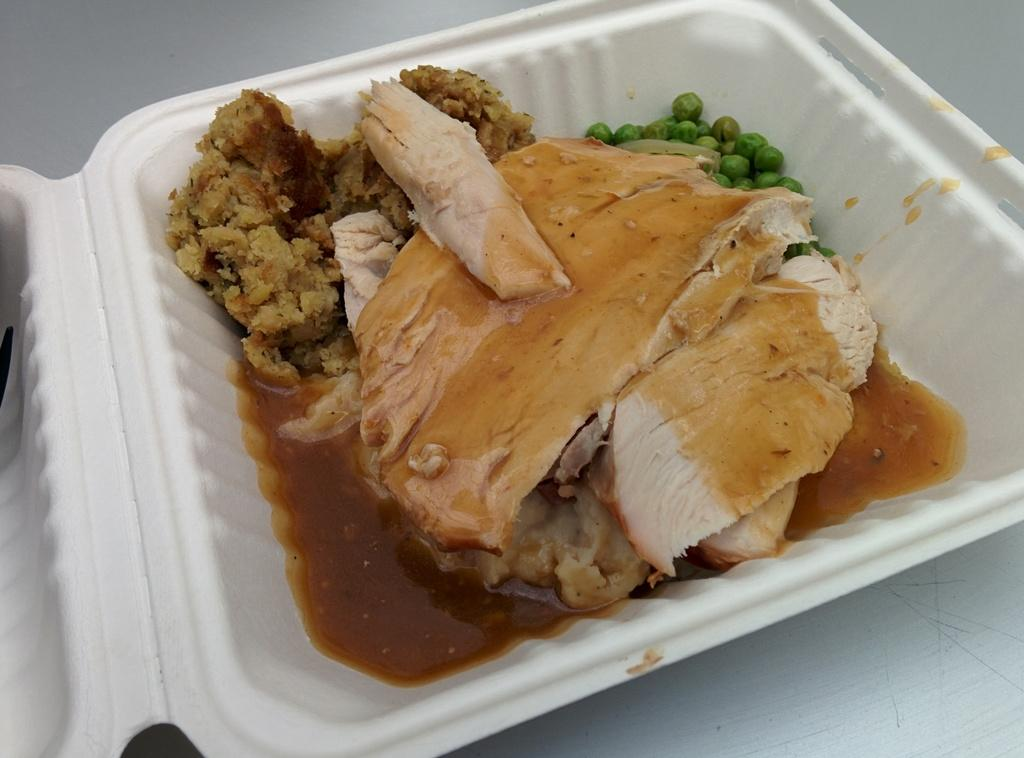What is the main object in the center of the image? There is a box in the center of the image. What is inside the box? The box contains food items. What type of beef is being served on the seat in the image? There is no beef or seat present in the image; it only features a box containing food items. 